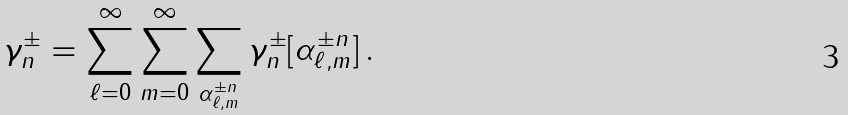<formula> <loc_0><loc_0><loc_500><loc_500>\gamma _ { n } ^ { \pm } = \sum _ { \ell = 0 } ^ { \infty } \sum _ { m = 0 } ^ { \infty } \sum _ { \alpha _ { \ell , m } ^ { \pm n } } \gamma _ { n } ^ { \pm } [ \alpha _ { \ell , m } ^ { \pm n } ] \, .</formula> 